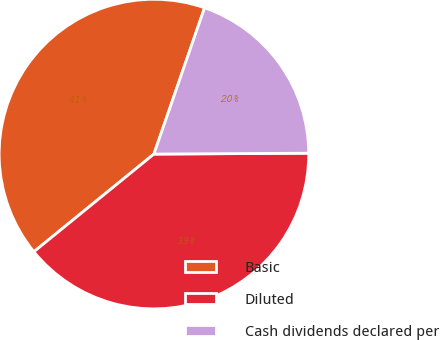Convert chart. <chart><loc_0><loc_0><loc_500><loc_500><pie_chart><fcel>Basic<fcel>Diluted<fcel>Cash dividends declared per<nl><fcel>41.18%<fcel>39.22%<fcel>19.61%<nl></chart> 